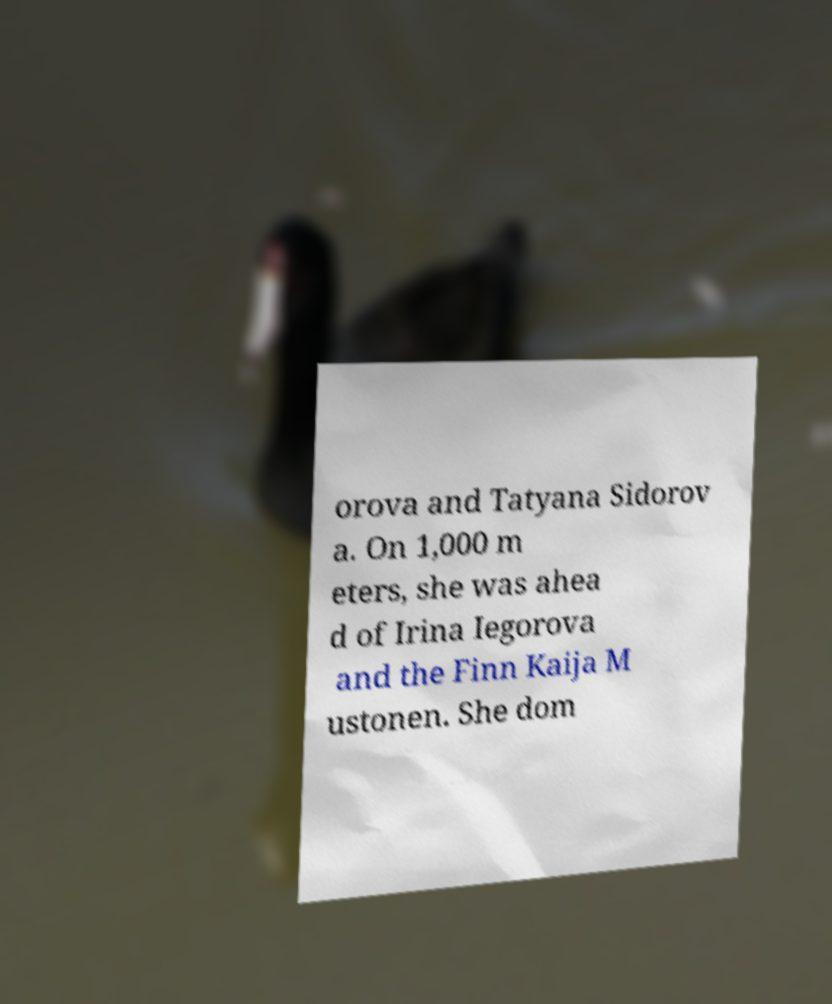For documentation purposes, I need the text within this image transcribed. Could you provide that? orova and Tatyana Sidorov a. On 1,000 m eters, she was ahea d of Irina Iegorova and the Finn Kaija M ustonen. She dom 